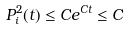<formula> <loc_0><loc_0><loc_500><loc_500>P _ { i } ^ { 2 } ( t ) \leq C e ^ { C t } \leq C</formula> 